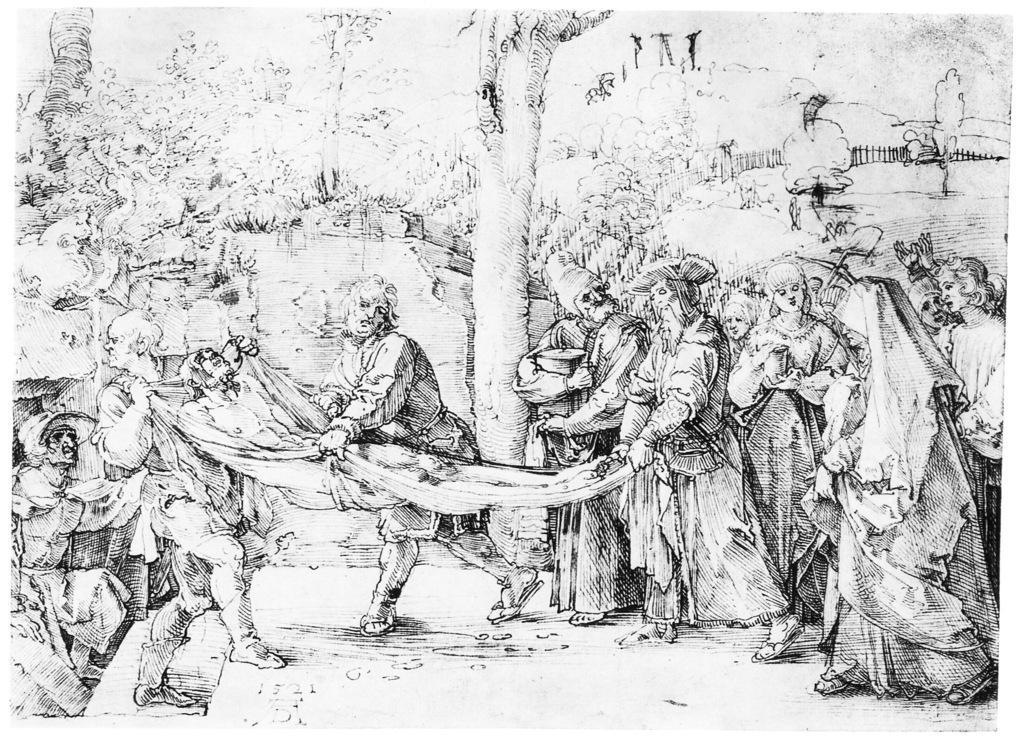Can you describe this image briefly? This picture shows art. we see trees and people standing and we see few of them holding a man with the help of a cloth. 